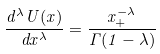<formula> <loc_0><loc_0><loc_500><loc_500>\frac { d ^ { \lambda } U ( x ) } { d x ^ { \lambda } } = \frac { x _ { + } ^ { - \lambda } } { \Gamma ( 1 - \lambda ) }</formula> 